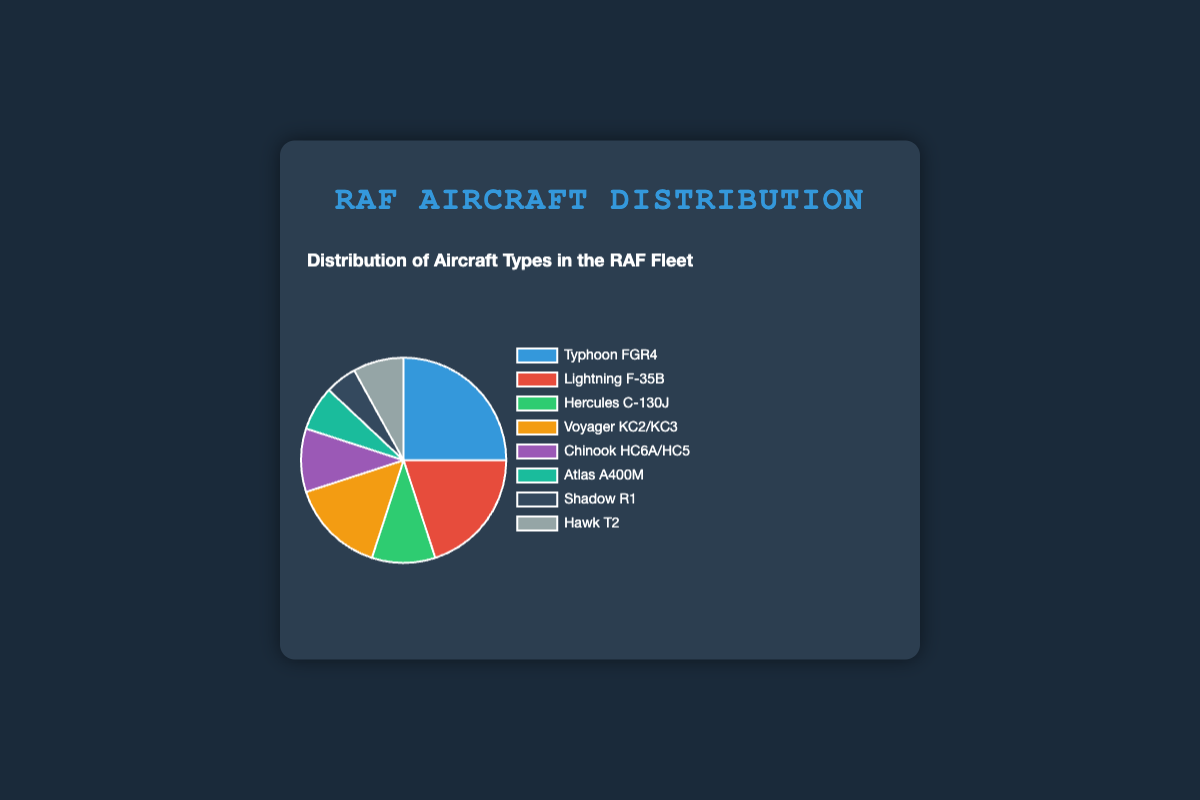What percentage of the RAF fleet is made up of the Lightning F-35B? To find this, refer to the slice labeled "Lightning F-35B" in the pie chart. The chart indicates that the Lightning F-35B makes up 20% of the fleet.
Answer: 20% Which aircraft type has the largest proportion in the RAF fleet? Look at the pie chart and identify the largest slice. The "Typhoon FGR4" slice is the largest, indicating it has the highest percentage.
Answer: Typhoon FGR4 How much greater is the percentage of Typhoon FGR4 compared to Hercules C-130J? The percentage of Typhoon FGR4 is 25% while Hercules C-130J is 10%. Subtract 10% from 25% to find the difference.
Answer: 15% What is the combined percentage of Atlas A400M and Shadow R1 in the RAF fleet? Find the percentages for Atlas A400M (7%) and Shadow R1 (5%) and add them together.
Answer: 12% Between Voyager KC2/KC3 and Chinook HC6A/HC5, which has a higher percentage and by how much? Voyager KC2/KC3 is 15%, and Chinook HC6A/HC5 is 10%. Subtract the smaller percentage from the larger one to find the difference.
Answer: Voyager KC2/KC3 by 5% What is the percentage difference between Hawk T2 and Lightning F-35B? Hawk T2 is 8% and Lightning F-35B is 20%. Subtract 8% from 20% to find the difference.
Answer: 12% What is the total percentage of the fleet taken up by Typhoon FGR4, Lightning F-35B, and Hercules C-130J? Add the percentages of Typhoon FGR4 (25%), Lightning F-35B (20%), and Hercules C-130J (10%).
Answer: 55% Which aircraft type has the smallest representation in the RAF fleet? The smallest slice in the pie chart represents the "Shadow R1" which is 5%.
Answer: Shadow R1 If the total number of aircraft is 200, how many are of the type Typhoon FGR4? Typhoon FGR4 represents 25% of the fleet. Multiply 200 by 0.25 to find the number of aircraft.
Answer: 50 Comparing Atlas A400M and Hawk T2, which has a larger slice, and what is the percentage difference? Hawk T2 has 8% and Atlas A400M has 7%. Subtract 7% from 8% to find the difference.
Answer: Hawk T2 by 1% 